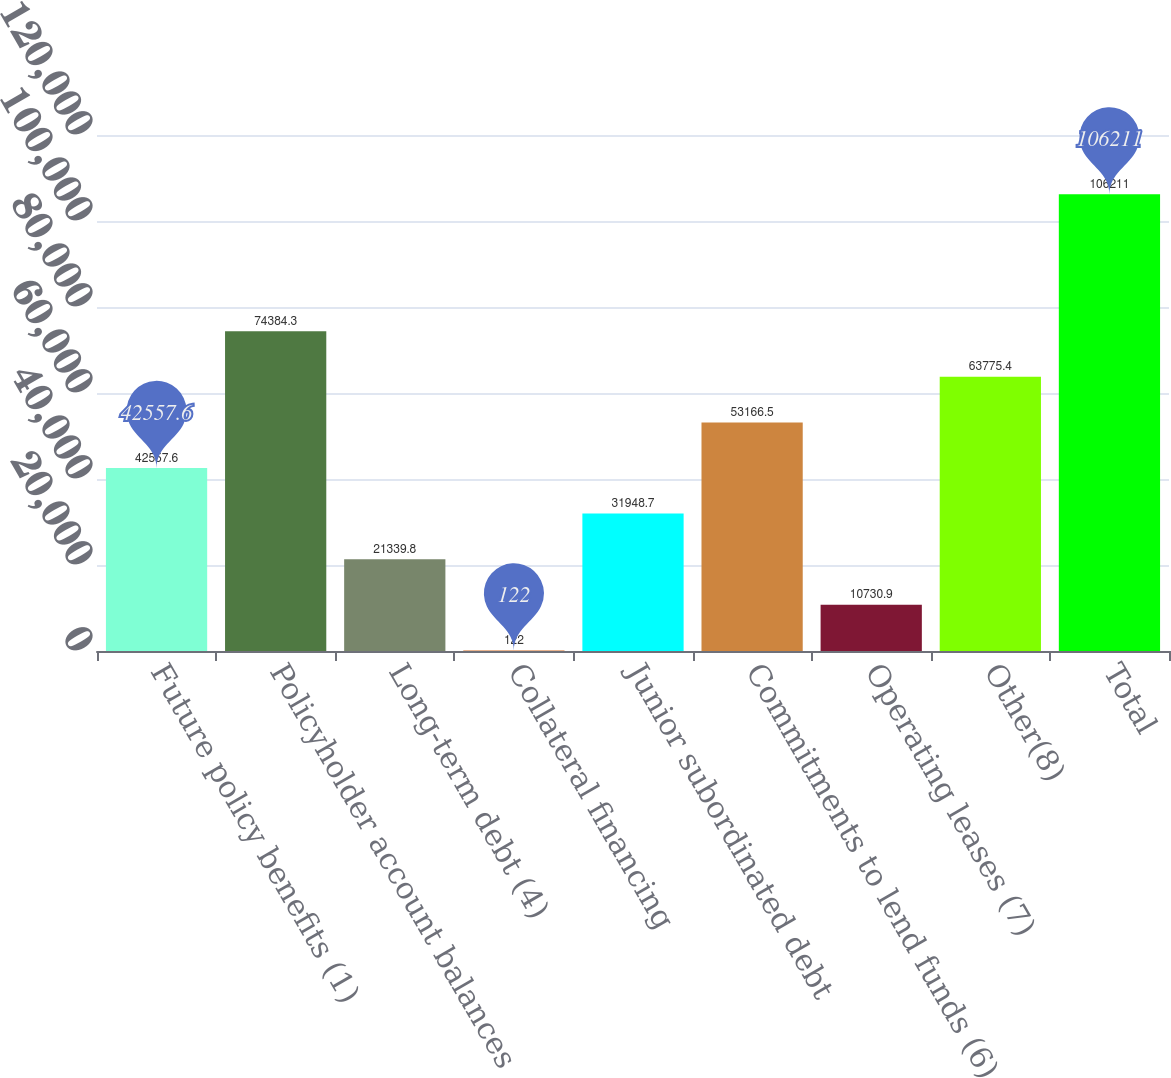Convert chart. <chart><loc_0><loc_0><loc_500><loc_500><bar_chart><fcel>Future policy benefits (1)<fcel>Policyholder account balances<fcel>Long-term debt (4)<fcel>Collateral financing<fcel>Junior subordinated debt<fcel>Commitments to lend funds (6)<fcel>Operating leases (7)<fcel>Other(8)<fcel>Total<nl><fcel>42557.6<fcel>74384.3<fcel>21339.8<fcel>122<fcel>31948.7<fcel>53166.5<fcel>10730.9<fcel>63775.4<fcel>106211<nl></chart> 